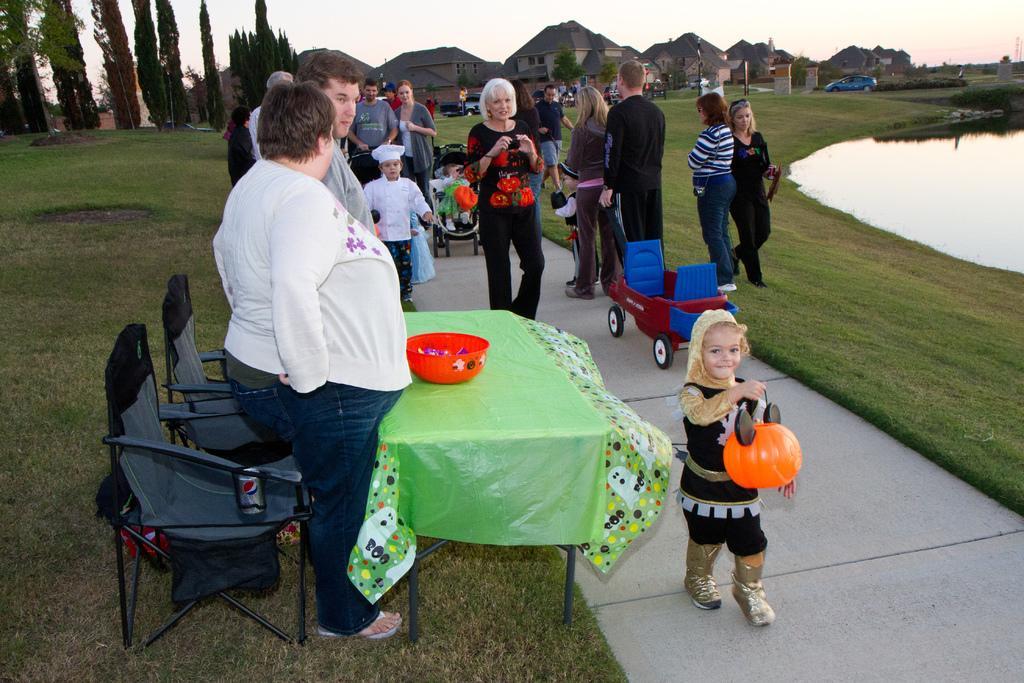Could you give a brief overview of what you see in this image? Completely and outdoor picture. Most of the persons are standing. Backside of this person's there are chairs, on this chair there is a tin. Far there are number of trees and buildings. This is a freshwater lake. Far there are vehicles. This kid is holding a toy. On this table there is a bowl. This is vehicle. Grass is in green color. 